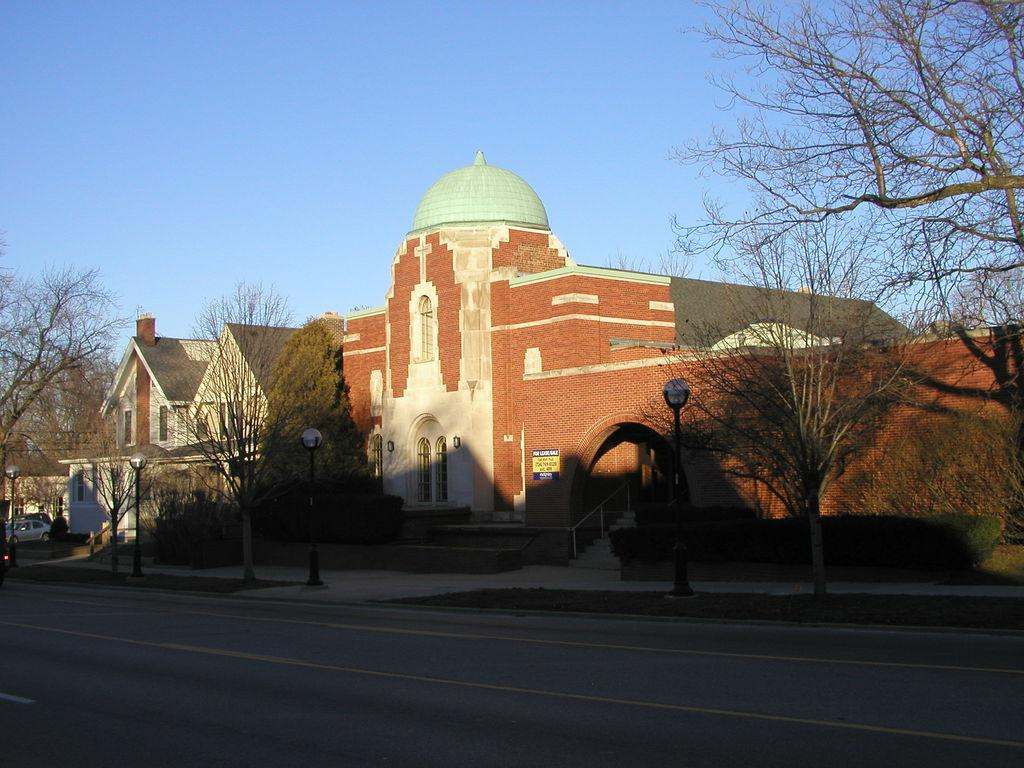What objects are located in the middle of the image? There are poles, trees, and vehicles in the middle of the image. What type of structures can be seen in the background of the image? There are buildings visible in the background of the image. What is visible at the top of the image? The sky is visible at the top of the image. Can you see any jelly being shared between the poles in the image? There is no jelly or any indication of sharing in the image; it features poles, trees, and vehicles in the middle. 